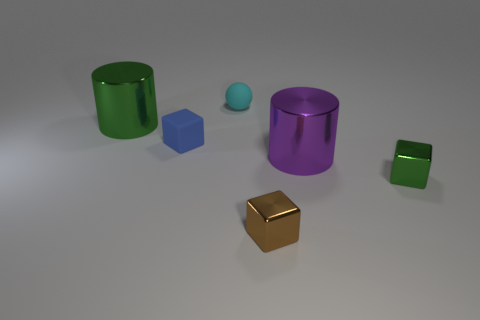Subtract all small blue matte cubes. How many cubes are left? 2 Subtract all purple cylinders. How many cylinders are left? 1 Add 2 green metal cylinders. How many objects exist? 8 Add 6 small brown metallic objects. How many small brown metallic objects exist? 7 Subtract 0 red cylinders. How many objects are left? 6 Subtract all cylinders. How many objects are left? 4 Subtract 1 balls. How many balls are left? 0 Subtract all blue blocks. Subtract all brown cylinders. How many blocks are left? 2 Subtract all red cubes. How many blue balls are left? 0 Subtract all large gray matte cylinders. Subtract all large green shiny things. How many objects are left? 5 